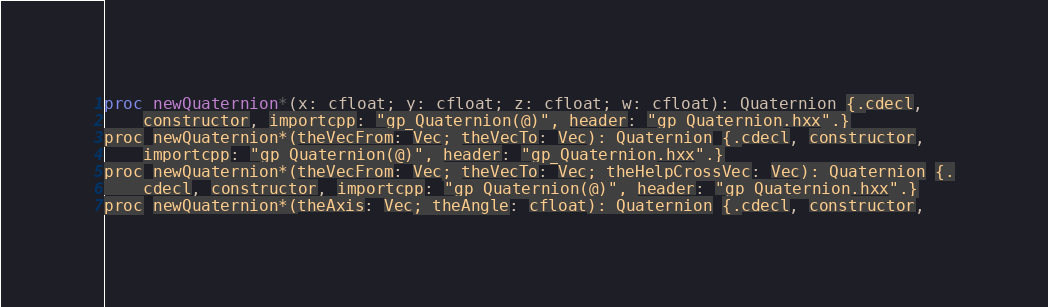Convert code to text. <code><loc_0><loc_0><loc_500><loc_500><_Nim_>proc newQuaternion*(x: cfloat; y: cfloat; z: cfloat; w: cfloat): Quaternion {.cdecl,
    constructor, importcpp: "gp_Quaternion(@)", header: "gp_Quaternion.hxx".}
proc newQuaternion*(theVecFrom: Vec; theVecTo: Vec): Quaternion {.cdecl, constructor,
    importcpp: "gp_Quaternion(@)", header: "gp_Quaternion.hxx".}
proc newQuaternion*(theVecFrom: Vec; theVecTo: Vec; theHelpCrossVec: Vec): Quaternion {.
    cdecl, constructor, importcpp: "gp_Quaternion(@)", header: "gp_Quaternion.hxx".}
proc newQuaternion*(theAxis: Vec; theAngle: cfloat): Quaternion {.cdecl, constructor,</code> 